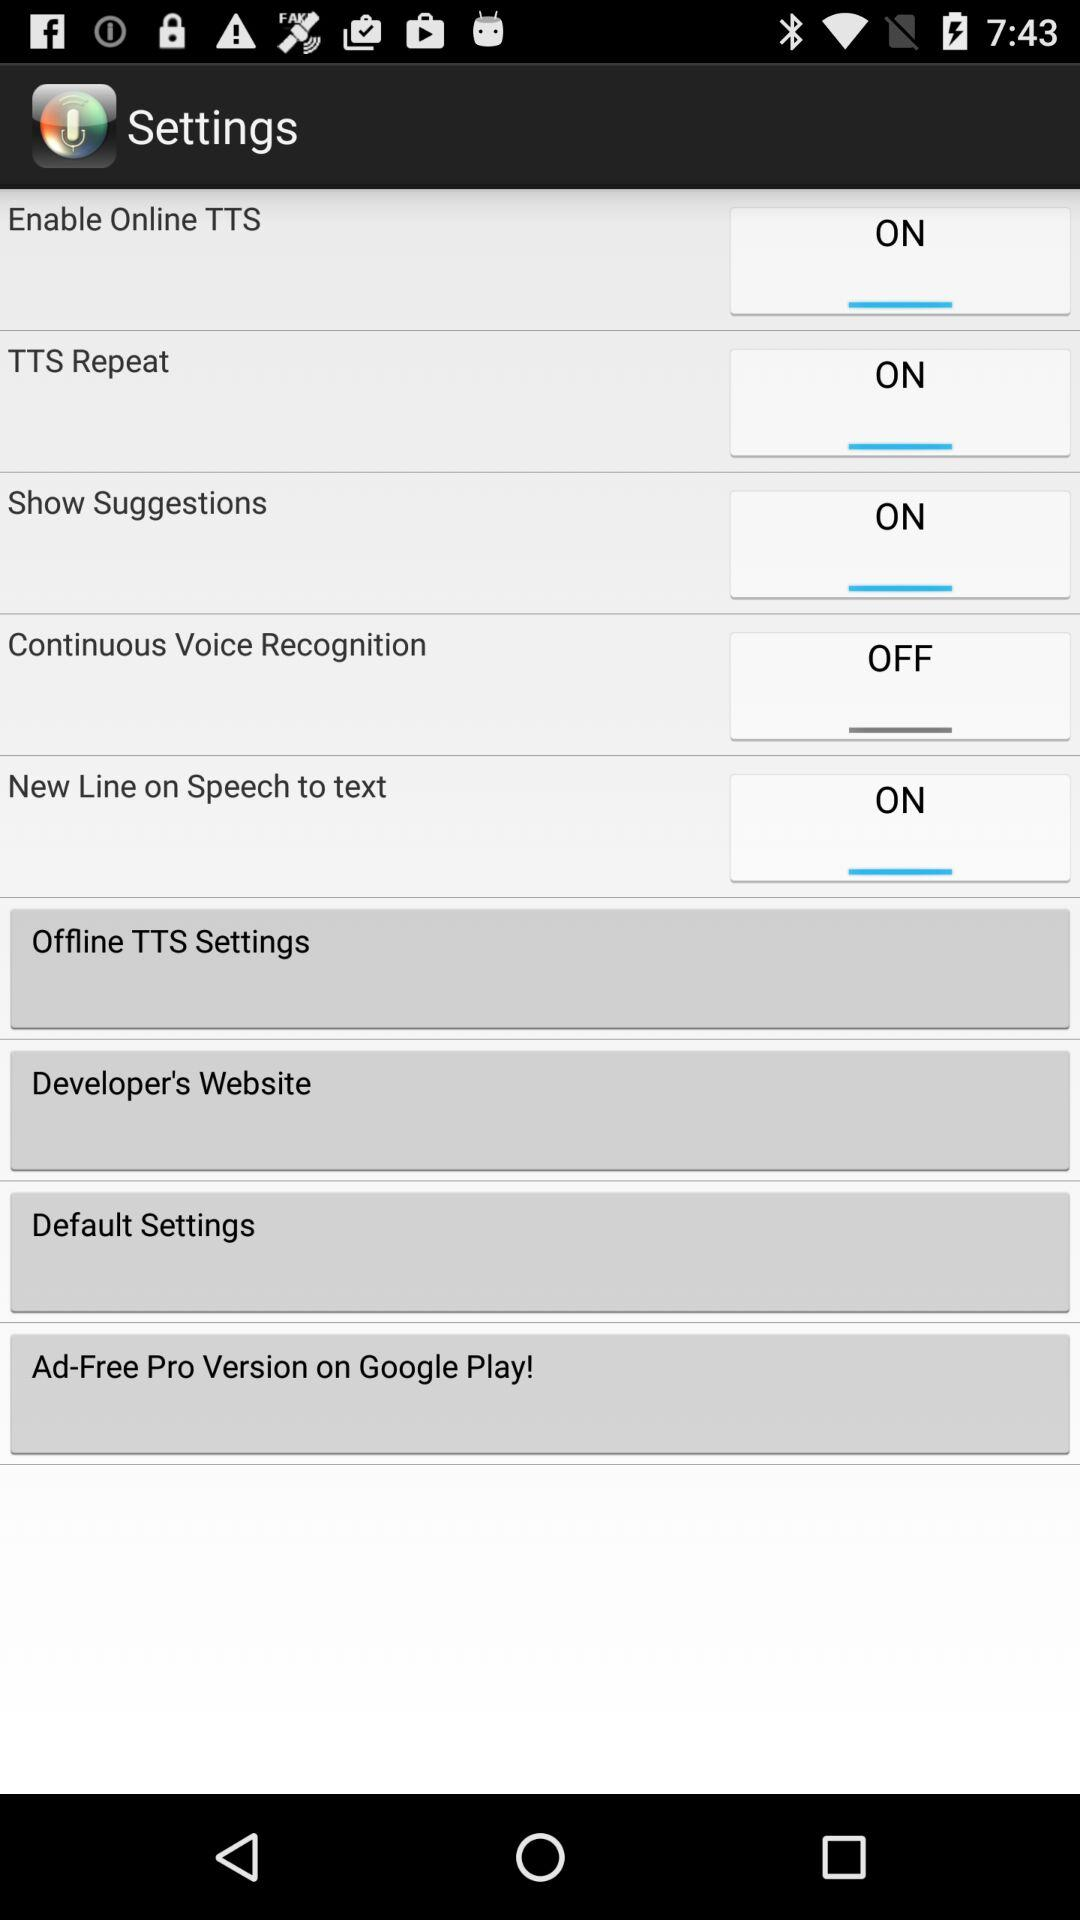How many settings options are there that are enabled?
Answer the question using a single word or phrase. 4 